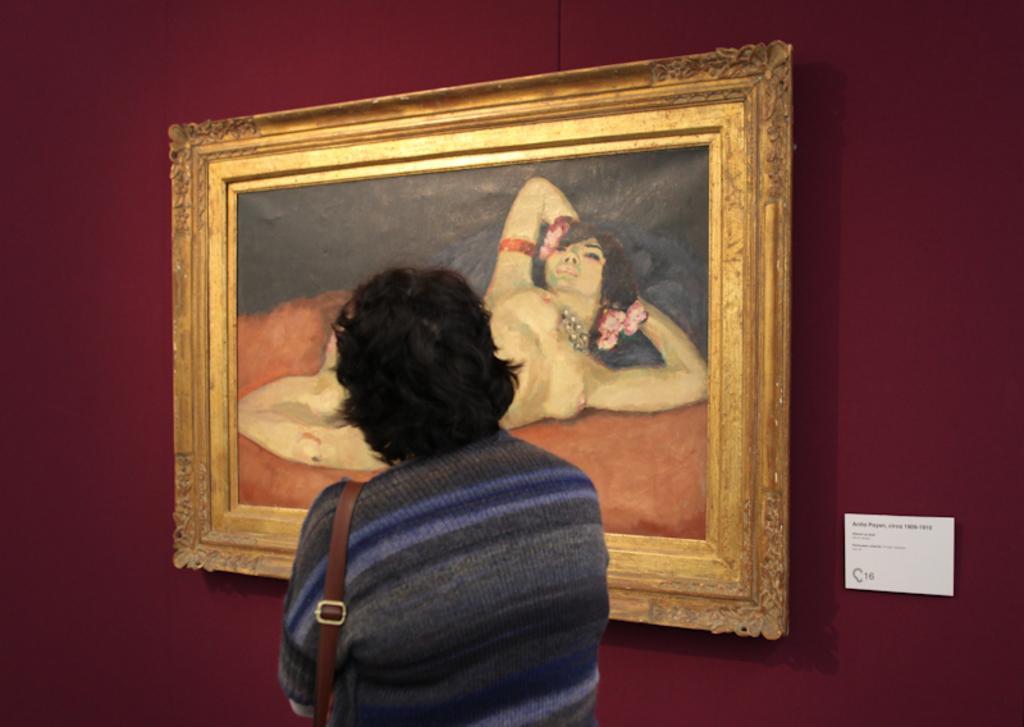Can you describe this image briefly? In this image, we can see a person wearing a sling bag. In the background, we can see a board and painting with frame are on the wall. 